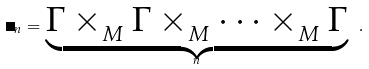Convert formula to latex. <formula><loc_0><loc_0><loc_500><loc_500>\Gamma _ { n } = \underbrace { \Gamma \times _ { _ { M } } \Gamma \times _ { _ { M } } \dots \times _ { _ { M } } \Gamma } _ { n } \ .</formula> 